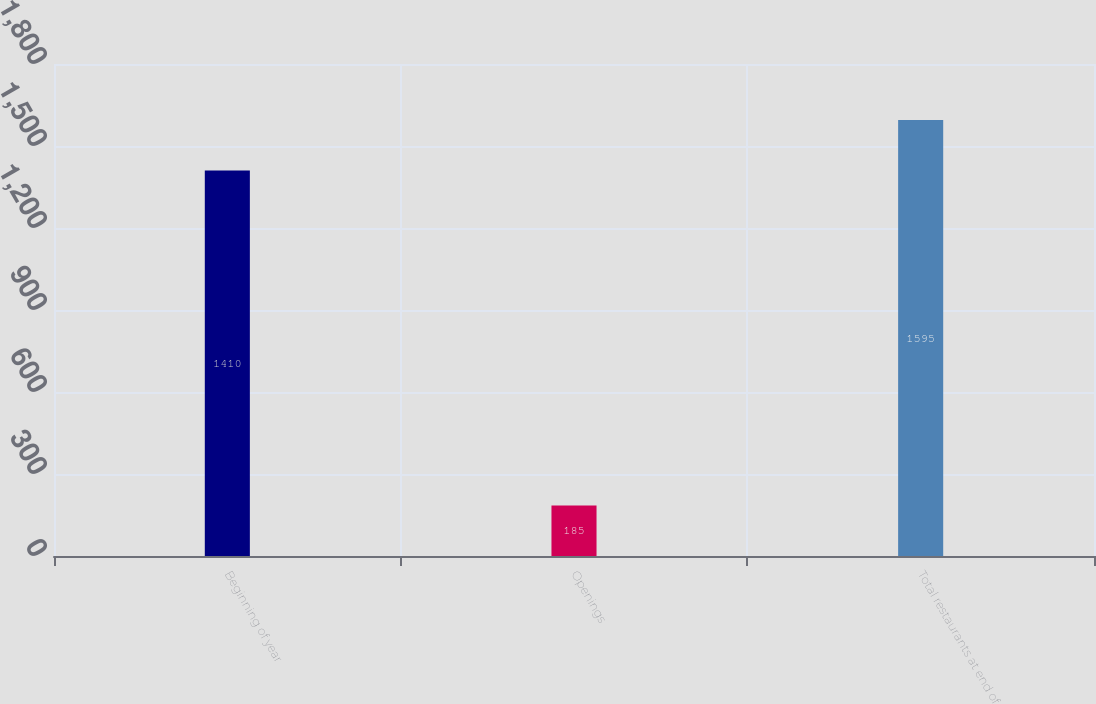Convert chart to OTSL. <chart><loc_0><loc_0><loc_500><loc_500><bar_chart><fcel>Beginning of year<fcel>Openings<fcel>Total restaurants at end of<nl><fcel>1410<fcel>185<fcel>1595<nl></chart> 